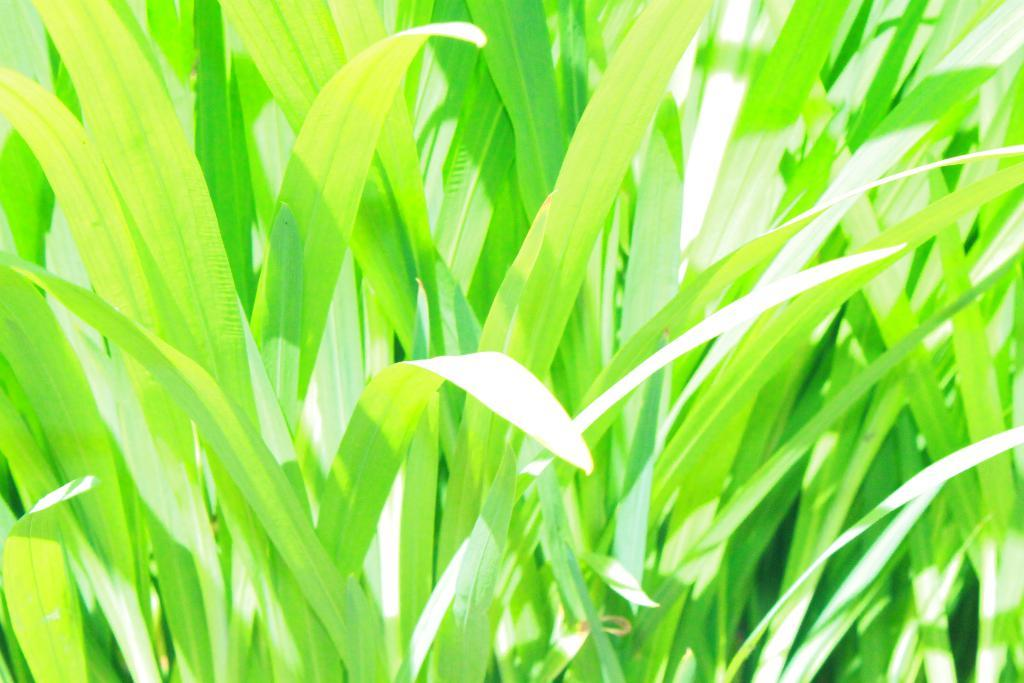What type of living organisms can be seen in the image? Plants can be seen in the image. What type of animal can be seen interacting with the plants in the image? There is no animal present in the image; it only features plants. What type of lipstick is being used on the plants in the image? There is no lipstick or any cosmetic product present in the image; it only features plants. 